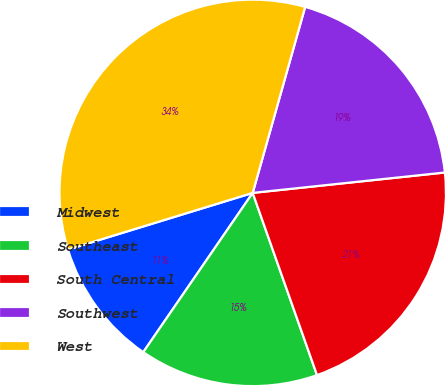Convert chart. <chart><loc_0><loc_0><loc_500><loc_500><pie_chart><fcel>Midwest<fcel>Southeast<fcel>South Central<fcel>Southwest<fcel>West<nl><fcel>10.68%<fcel>14.98%<fcel>21.28%<fcel>18.94%<fcel>34.11%<nl></chart> 